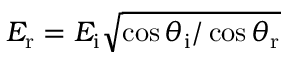Convert formula to latex. <formula><loc_0><loc_0><loc_500><loc_500>E _ { r } = E _ { i } \sqrt { \cos \theta _ { i } / \cos \theta _ { r } }</formula> 